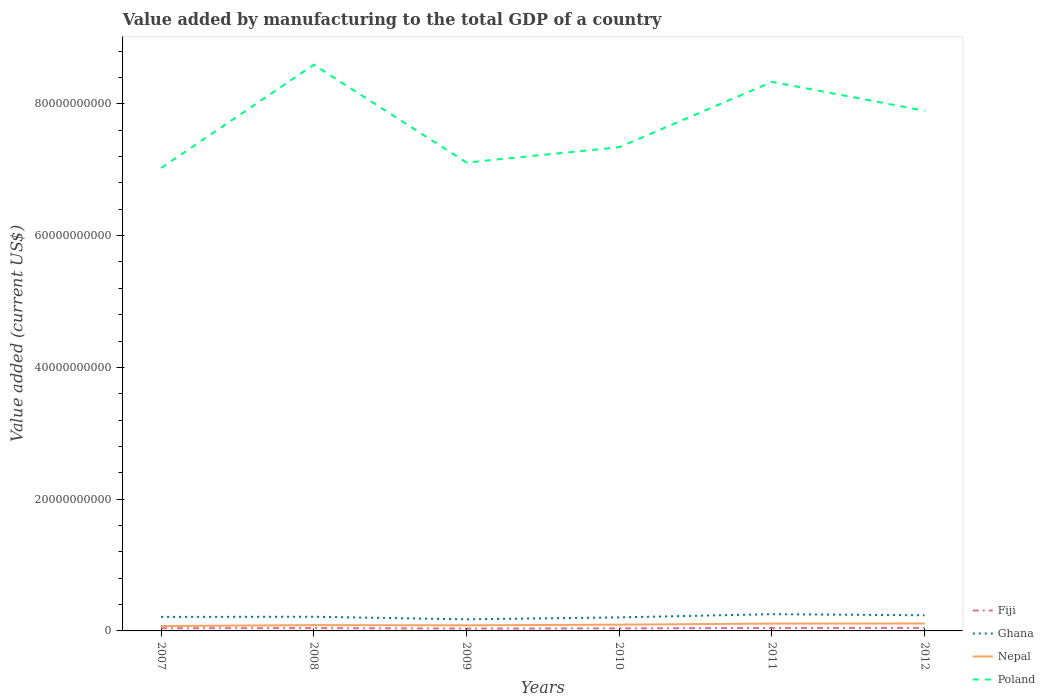Across all years, what is the maximum value added by manufacturing to the total GDP in Ghana?
Your answer should be compact. 1.76e+09. In which year was the value added by manufacturing to the total GDP in Nepal maximum?
Your answer should be compact. 2007. What is the total value added by manufacturing to the total GDP in Ghana in the graph?
Your response must be concise. 3.93e+08. What is the difference between the highest and the second highest value added by manufacturing to the total GDP in Nepal?
Your response must be concise. 3.85e+08. How many years are there in the graph?
Offer a very short reply. 6. Are the values on the major ticks of Y-axis written in scientific E-notation?
Keep it short and to the point. No. Does the graph contain grids?
Your answer should be compact. No. How many legend labels are there?
Provide a short and direct response. 4. How are the legend labels stacked?
Offer a terse response. Vertical. What is the title of the graph?
Make the answer very short. Value added by manufacturing to the total GDP of a country. Does "Mali" appear as one of the legend labels in the graph?
Provide a short and direct response. No. What is the label or title of the Y-axis?
Your response must be concise. Value added (current US$). What is the Value added (current US$) of Fiji in 2007?
Provide a succinct answer. 4.09e+08. What is the Value added (current US$) of Ghana in 2007?
Ensure brevity in your answer.  2.13e+09. What is the Value added (current US$) of Nepal in 2007?
Your answer should be very brief. 7.40e+08. What is the Value added (current US$) of Poland in 2007?
Keep it short and to the point. 7.03e+1. What is the Value added (current US$) of Fiji in 2008?
Make the answer very short. 4.28e+08. What is the Value added (current US$) in Ghana in 2008?
Provide a succinct answer. 2.15e+09. What is the Value added (current US$) of Nepal in 2008?
Provide a short and direct response. 8.80e+08. What is the Value added (current US$) in Poland in 2008?
Ensure brevity in your answer.  8.59e+1. What is the Value added (current US$) in Fiji in 2009?
Your answer should be compact. 3.53e+08. What is the Value added (current US$) of Ghana in 2009?
Make the answer very short. 1.76e+09. What is the Value added (current US$) in Nepal in 2009?
Make the answer very short. 8.51e+08. What is the Value added (current US$) in Poland in 2009?
Make the answer very short. 7.11e+1. What is the Value added (current US$) in Fiji in 2010?
Offer a very short reply. 3.87e+08. What is the Value added (current US$) in Ghana in 2010?
Offer a very short reply. 2.06e+09. What is the Value added (current US$) in Nepal in 2010?
Keep it short and to the point. 9.52e+08. What is the Value added (current US$) in Poland in 2010?
Your answer should be compact. 7.34e+1. What is the Value added (current US$) of Fiji in 2011?
Make the answer very short. 4.50e+08. What is the Value added (current US$) in Ghana in 2011?
Offer a very short reply. 2.54e+09. What is the Value added (current US$) of Nepal in 2011?
Ensure brevity in your answer.  1.11e+09. What is the Value added (current US$) in Poland in 2011?
Provide a short and direct response. 8.33e+1. What is the Value added (current US$) in Fiji in 2012?
Offer a very short reply. 4.59e+08. What is the Value added (current US$) in Ghana in 2012?
Give a very brief answer. 2.37e+09. What is the Value added (current US$) of Nepal in 2012?
Make the answer very short. 1.13e+09. What is the Value added (current US$) in Poland in 2012?
Provide a succinct answer. 7.89e+1. Across all years, what is the maximum Value added (current US$) of Fiji?
Your response must be concise. 4.59e+08. Across all years, what is the maximum Value added (current US$) of Ghana?
Provide a succinct answer. 2.54e+09. Across all years, what is the maximum Value added (current US$) of Nepal?
Your answer should be compact. 1.13e+09. Across all years, what is the maximum Value added (current US$) of Poland?
Provide a short and direct response. 8.59e+1. Across all years, what is the minimum Value added (current US$) in Fiji?
Make the answer very short. 3.53e+08. Across all years, what is the minimum Value added (current US$) in Ghana?
Provide a succinct answer. 1.76e+09. Across all years, what is the minimum Value added (current US$) in Nepal?
Your response must be concise. 7.40e+08. Across all years, what is the minimum Value added (current US$) in Poland?
Your answer should be very brief. 7.03e+1. What is the total Value added (current US$) of Fiji in the graph?
Provide a short and direct response. 2.49e+09. What is the total Value added (current US$) of Ghana in the graph?
Your answer should be compact. 1.30e+1. What is the total Value added (current US$) in Nepal in the graph?
Ensure brevity in your answer.  5.66e+09. What is the total Value added (current US$) in Poland in the graph?
Your answer should be very brief. 4.63e+11. What is the difference between the Value added (current US$) in Fiji in 2007 and that in 2008?
Your answer should be compact. -1.92e+07. What is the difference between the Value added (current US$) of Ghana in 2007 and that in 2008?
Ensure brevity in your answer.  -2.37e+07. What is the difference between the Value added (current US$) of Nepal in 2007 and that in 2008?
Give a very brief answer. -1.39e+08. What is the difference between the Value added (current US$) of Poland in 2007 and that in 2008?
Your response must be concise. -1.57e+1. What is the difference between the Value added (current US$) of Fiji in 2007 and that in 2009?
Your response must be concise. 5.59e+07. What is the difference between the Value added (current US$) of Ghana in 2007 and that in 2009?
Your answer should be very brief. 3.69e+08. What is the difference between the Value added (current US$) in Nepal in 2007 and that in 2009?
Ensure brevity in your answer.  -1.11e+08. What is the difference between the Value added (current US$) of Poland in 2007 and that in 2009?
Offer a very short reply. -8.25e+08. What is the difference between the Value added (current US$) in Fiji in 2007 and that in 2010?
Offer a very short reply. 2.25e+07. What is the difference between the Value added (current US$) in Ghana in 2007 and that in 2010?
Give a very brief answer. 7.28e+07. What is the difference between the Value added (current US$) in Nepal in 2007 and that in 2010?
Ensure brevity in your answer.  -2.11e+08. What is the difference between the Value added (current US$) in Poland in 2007 and that in 2010?
Give a very brief answer. -3.16e+09. What is the difference between the Value added (current US$) in Fiji in 2007 and that in 2011?
Give a very brief answer. -4.10e+07. What is the difference between the Value added (current US$) of Ghana in 2007 and that in 2011?
Provide a short and direct response. -4.13e+08. What is the difference between the Value added (current US$) in Nepal in 2007 and that in 2011?
Your answer should be compact. -3.74e+08. What is the difference between the Value added (current US$) of Poland in 2007 and that in 2011?
Your response must be concise. -1.31e+1. What is the difference between the Value added (current US$) in Fiji in 2007 and that in 2012?
Ensure brevity in your answer.  -5.01e+07. What is the difference between the Value added (current US$) in Ghana in 2007 and that in 2012?
Your answer should be very brief. -2.46e+08. What is the difference between the Value added (current US$) of Nepal in 2007 and that in 2012?
Make the answer very short. -3.85e+08. What is the difference between the Value added (current US$) in Poland in 2007 and that in 2012?
Give a very brief answer. -8.69e+09. What is the difference between the Value added (current US$) of Fiji in 2008 and that in 2009?
Make the answer very short. 7.51e+07. What is the difference between the Value added (current US$) in Ghana in 2008 and that in 2009?
Your answer should be compact. 3.93e+08. What is the difference between the Value added (current US$) in Nepal in 2008 and that in 2009?
Provide a short and direct response. 2.82e+07. What is the difference between the Value added (current US$) of Poland in 2008 and that in 2009?
Make the answer very short. 1.48e+1. What is the difference between the Value added (current US$) of Fiji in 2008 and that in 2010?
Your answer should be compact. 4.17e+07. What is the difference between the Value added (current US$) of Ghana in 2008 and that in 2010?
Provide a succinct answer. 9.66e+07. What is the difference between the Value added (current US$) of Nepal in 2008 and that in 2010?
Ensure brevity in your answer.  -7.20e+07. What is the difference between the Value added (current US$) of Poland in 2008 and that in 2010?
Your response must be concise. 1.25e+1. What is the difference between the Value added (current US$) in Fiji in 2008 and that in 2011?
Keep it short and to the point. -2.18e+07. What is the difference between the Value added (current US$) in Ghana in 2008 and that in 2011?
Provide a succinct answer. -3.90e+08. What is the difference between the Value added (current US$) of Nepal in 2008 and that in 2011?
Keep it short and to the point. -2.35e+08. What is the difference between the Value added (current US$) of Poland in 2008 and that in 2011?
Provide a succinct answer. 2.60e+09. What is the difference between the Value added (current US$) of Fiji in 2008 and that in 2012?
Offer a very short reply. -3.10e+07. What is the difference between the Value added (current US$) of Ghana in 2008 and that in 2012?
Make the answer very short. -2.22e+08. What is the difference between the Value added (current US$) of Nepal in 2008 and that in 2012?
Your answer should be compact. -2.46e+08. What is the difference between the Value added (current US$) in Poland in 2008 and that in 2012?
Keep it short and to the point. 6.98e+09. What is the difference between the Value added (current US$) of Fiji in 2009 and that in 2010?
Offer a very short reply. -3.34e+07. What is the difference between the Value added (current US$) in Ghana in 2009 and that in 2010?
Ensure brevity in your answer.  -2.96e+08. What is the difference between the Value added (current US$) in Nepal in 2009 and that in 2010?
Your answer should be compact. -1.00e+08. What is the difference between the Value added (current US$) of Poland in 2009 and that in 2010?
Your answer should be compact. -2.33e+09. What is the difference between the Value added (current US$) in Fiji in 2009 and that in 2011?
Keep it short and to the point. -9.69e+07. What is the difference between the Value added (current US$) in Ghana in 2009 and that in 2011?
Offer a very short reply. -7.82e+08. What is the difference between the Value added (current US$) in Nepal in 2009 and that in 2011?
Provide a succinct answer. -2.63e+08. What is the difference between the Value added (current US$) of Poland in 2009 and that in 2011?
Make the answer very short. -1.22e+1. What is the difference between the Value added (current US$) of Fiji in 2009 and that in 2012?
Ensure brevity in your answer.  -1.06e+08. What is the difference between the Value added (current US$) of Ghana in 2009 and that in 2012?
Offer a terse response. -6.15e+08. What is the difference between the Value added (current US$) in Nepal in 2009 and that in 2012?
Keep it short and to the point. -2.74e+08. What is the difference between the Value added (current US$) of Poland in 2009 and that in 2012?
Offer a terse response. -7.86e+09. What is the difference between the Value added (current US$) in Fiji in 2010 and that in 2011?
Provide a short and direct response. -6.35e+07. What is the difference between the Value added (current US$) of Ghana in 2010 and that in 2011?
Offer a very short reply. -4.86e+08. What is the difference between the Value added (current US$) of Nepal in 2010 and that in 2011?
Provide a short and direct response. -1.63e+08. What is the difference between the Value added (current US$) of Poland in 2010 and that in 2011?
Keep it short and to the point. -9.91e+09. What is the difference between the Value added (current US$) of Fiji in 2010 and that in 2012?
Keep it short and to the point. -7.26e+07. What is the difference between the Value added (current US$) of Ghana in 2010 and that in 2012?
Your response must be concise. -3.18e+08. What is the difference between the Value added (current US$) in Nepal in 2010 and that in 2012?
Offer a very short reply. -1.74e+08. What is the difference between the Value added (current US$) of Poland in 2010 and that in 2012?
Make the answer very short. -5.53e+09. What is the difference between the Value added (current US$) in Fiji in 2011 and that in 2012?
Offer a terse response. -9.15e+06. What is the difference between the Value added (current US$) in Ghana in 2011 and that in 2012?
Ensure brevity in your answer.  1.68e+08. What is the difference between the Value added (current US$) of Nepal in 2011 and that in 2012?
Your answer should be compact. -1.10e+07. What is the difference between the Value added (current US$) of Poland in 2011 and that in 2012?
Ensure brevity in your answer.  4.38e+09. What is the difference between the Value added (current US$) in Fiji in 2007 and the Value added (current US$) in Ghana in 2008?
Your answer should be very brief. -1.74e+09. What is the difference between the Value added (current US$) in Fiji in 2007 and the Value added (current US$) in Nepal in 2008?
Offer a very short reply. -4.70e+08. What is the difference between the Value added (current US$) of Fiji in 2007 and the Value added (current US$) of Poland in 2008?
Your response must be concise. -8.55e+1. What is the difference between the Value added (current US$) in Ghana in 2007 and the Value added (current US$) in Nepal in 2008?
Provide a succinct answer. 1.25e+09. What is the difference between the Value added (current US$) in Ghana in 2007 and the Value added (current US$) in Poland in 2008?
Your answer should be very brief. -8.38e+1. What is the difference between the Value added (current US$) of Nepal in 2007 and the Value added (current US$) of Poland in 2008?
Your response must be concise. -8.52e+1. What is the difference between the Value added (current US$) in Fiji in 2007 and the Value added (current US$) in Ghana in 2009?
Make the answer very short. -1.35e+09. What is the difference between the Value added (current US$) in Fiji in 2007 and the Value added (current US$) in Nepal in 2009?
Make the answer very short. -4.42e+08. What is the difference between the Value added (current US$) in Fiji in 2007 and the Value added (current US$) in Poland in 2009?
Your answer should be very brief. -7.07e+1. What is the difference between the Value added (current US$) in Ghana in 2007 and the Value added (current US$) in Nepal in 2009?
Give a very brief answer. 1.28e+09. What is the difference between the Value added (current US$) in Ghana in 2007 and the Value added (current US$) in Poland in 2009?
Your answer should be very brief. -6.90e+1. What is the difference between the Value added (current US$) of Nepal in 2007 and the Value added (current US$) of Poland in 2009?
Your response must be concise. -7.03e+1. What is the difference between the Value added (current US$) in Fiji in 2007 and the Value added (current US$) in Ghana in 2010?
Keep it short and to the point. -1.65e+09. What is the difference between the Value added (current US$) in Fiji in 2007 and the Value added (current US$) in Nepal in 2010?
Your response must be concise. -5.42e+08. What is the difference between the Value added (current US$) of Fiji in 2007 and the Value added (current US$) of Poland in 2010?
Offer a terse response. -7.30e+1. What is the difference between the Value added (current US$) in Ghana in 2007 and the Value added (current US$) in Nepal in 2010?
Provide a succinct answer. 1.18e+09. What is the difference between the Value added (current US$) in Ghana in 2007 and the Value added (current US$) in Poland in 2010?
Offer a terse response. -7.13e+1. What is the difference between the Value added (current US$) of Nepal in 2007 and the Value added (current US$) of Poland in 2010?
Keep it short and to the point. -7.27e+1. What is the difference between the Value added (current US$) of Fiji in 2007 and the Value added (current US$) of Ghana in 2011?
Offer a very short reply. -2.13e+09. What is the difference between the Value added (current US$) in Fiji in 2007 and the Value added (current US$) in Nepal in 2011?
Give a very brief answer. -7.05e+08. What is the difference between the Value added (current US$) of Fiji in 2007 and the Value added (current US$) of Poland in 2011?
Offer a terse response. -8.29e+1. What is the difference between the Value added (current US$) in Ghana in 2007 and the Value added (current US$) in Nepal in 2011?
Offer a terse response. 1.01e+09. What is the difference between the Value added (current US$) of Ghana in 2007 and the Value added (current US$) of Poland in 2011?
Ensure brevity in your answer.  -8.12e+1. What is the difference between the Value added (current US$) of Nepal in 2007 and the Value added (current US$) of Poland in 2011?
Provide a succinct answer. -8.26e+1. What is the difference between the Value added (current US$) in Fiji in 2007 and the Value added (current US$) in Ghana in 2012?
Your response must be concise. -1.96e+09. What is the difference between the Value added (current US$) of Fiji in 2007 and the Value added (current US$) of Nepal in 2012?
Keep it short and to the point. -7.16e+08. What is the difference between the Value added (current US$) in Fiji in 2007 and the Value added (current US$) in Poland in 2012?
Make the answer very short. -7.85e+1. What is the difference between the Value added (current US$) in Ghana in 2007 and the Value added (current US$) in Nepal in 2012?
Provide a short and direct response. 1.00e+09. What is the difference between the Value added (current US$) of Ghana in 2007 and the Value added (current US$) of Poland in 2012?
Make the answer very short. -7.68e+1. What is the difference between the Value added (current US$) in Nepal in 2007 and the Value added (current US$) in Poland in 2012?
Your answer should be compact. -7.82e+1. What is the difference between the Value added (current US$) of Fiji in 2008 and the Value added (current US$) of Ghana in 2009?
Offer a terse response. -1.33e+09. What is the difference between the Value added (current US$) of Fiji in 2008 and the Value added (current US$) of Nepal in 2009?
Provide a short and direct response. -4.23e+08. What is the difference between the Value added (current US$) in Fiji in 2008 and the Value added (current US$) in Poland in 2009?
Keep it short and to the point. -7.07e+1. What is the difference between the Value added (current US$) in Ghana in 2008 and the Value added (current US$) in Nepal in 2009?
Your answer should be very brief. 1.30e+09. What is the difference between the Value added (current US$) of Ghana in 2008 and the Value added (current US$) of Poland in 2009?
Your answer should be compact. -6.89e+1. What is the difference between the Value added (current US$) of Nepal in 2008 and the Value added (current US$) of Poland in 2009?
Ensure brevity in your answer.  -7.02e+1. What is the difference between the Value added (current US$) in Fiji in 2008 and the Value added (current US$) in Ghana in 2010?
Keep it short and to the point. -1.63e+09. What is the difference between the Value added (current US$) in Fiji in 2008 and the Value added (current US$) in Nepal in 2010?
Your answer should be very brief. -5.23e+08. What is the difference between the Value added (current US$) in Fiji in 2008 and the Value added (current US$) in Poland in 2010?
Ensure brevity in your answer.  -7.30e+1. What is the difference between the Value added (current US$) in Ghana in 2008 and the Value added (current US$) in Nepal in 2010?
Ensure brevity in your answer.  1.20e+09. What is the difference between the Value added (current US$) of Ghana in 2008 and the Value added (current US$) of Poland in 2010?
Your answer should be very brief. -7.13e+1. What is the difference between the Value added (current US$) of Nepal in 2008 and the Value added (current US$) of Poland in 2010?
Offer a terse response. -7.25e+1. What is the difference between the Value added (current US$) of Fiji in 2008 and the Value added (current US$) of Ghana in 2011?
Keep it short and to the point. -2.11e+09. What is the difference between the Value added (current US$) of Fiji in 2008 and the Value added (current US$) of Nepal in 2011?
Provide a succinct answer. -6.86e+08. What is the difference between the Value added (current US$) in Fiji in 2008 and the Value added (current US$) in Poland in 2011?
Provide a short and direct response. -8.29e+1. What is the difference between the Value added (current US$) of Ghana in 2008 and the Value added (current US$) of Nepal in 2011?
Keep it short and to the point. 1.04e+09. What is the difference between the Value added (current US$) in Ghana in 2008 and the Value added (current US$) in Poland in 2011?
Your response must be concise. -8.12e+1. What is the difference between the Value added (current US$) in Nepal in 2008 and the Value added (current US$) in Poland in 2011?
Offer a terse response. -8.24e+1. What is the difference between the Value added (current US$) of Fiji in 2008 and the Value added (current US$) of Ghana in 2012?
Make the answer very short. -1.95e+09. What is the difference between the Value added (current US$) in Fiji in 2008 and the Value added (current US$) in Nepal in 2012?
Your response must be concise. -6.97e+08. What is the difference between the Value added (current US$) of Fiji in 2008 and the Value added (current US$) of Poland in 2012?
Offer a terse response. -7.85e+1. What is the difference between the Value added (current US$) in Ghana in 2008 and the Value added (current US$) in Nepal in 2012?
Your answer should be compact. 1.03e+09. What is the difference between the Value added (current US$) of Ghana in 2008 and the Value added (current US$) of Poland in 2012?
Your answer should be very brief. -7.68e+1. What is the difference between the Value added (current US$) of Nepal in 2008 and the Value added (current US$) of Poland in 2012?
Your answer should be very brief. -7.81e+1. What is the difference between the Value added (current US$) of Fiji in 2009 and the Value added (current US$) of Ghana in 2010?
Give a very brief answer. -1.70e+09. What is the difference between the Value added (current US$) of Fiji in 2009 and the Value added (current US$) of Nepal in 2010?
Your response must be concise. -5.98e+08. What is the difference between the Value added (current US$) of Fiji in 2009 and the Value added (current US$) of Poland in 2010?
Your answer should be compact. -7.31e+1. What is the difference between the Value added (current US$) in Ghana in 2009 and the Value added (current US$) in Nepal in 2010?
Give a very brief answer. 8.08e+08. What is the difference between the Value added (current US$) in Ghana in 2009 and the Value added (current US$) in Poland in 2010?
Provide a succinct answer. -7.17e+1. What is the difference between the Value added (current US$) of Nepal in 2009 and the Value added (current US$) of Poland in 2010?
Your response must be concise. -7.26e+1. What is the difference between the Value added (current US$) in Fiji in 2009 and the Value added (current US$) in Ghana in 2011?
Provide a succinct answer. -2.19e+09. What is the difference between the Value added (current US$) of Fiji in 2009 and the Value added (current US$) of Nepal in 2011?
Provide a succinct answer. -7.61e+08. What is the difference between the Value added (current US$) of Fiji in 2009 and the Value added (current US$) of Poland in 2011?
Provide a succinct answer. -8.30e+1. What is the difference between the Value added (current US$) of Ghana in 2009 and the Value added (current US$) of Nepal in 2011?
Give a very brief answer. 6.45e+08. What is the difference between the Value added (current US$) of Ghana in 2009 and the Value added (current US$) of Poland in 2011?
Offer a terse response. -8.16e+1. What is the difference between the Value added (current US$) of Nepal in 2009 and the Value added (current US$) of Poland in 2011?
Keep it short and to the point. -8.25e+1. What is the difference between the Value added (current US$) of Fiji in 2009 and the Value added (current US$) of Ghana in 2012?
Your answer should be very brief. -2.02e+09. What is the difference between the Value added (current US$) in Fiji in 2009 and the Value added (current US$) in Nepal in 2012?
Your answer should be compact. -7.72e+08. What is the difference between the Value added (current US$) of Fiji in 2009 and the Value added (current US$) of Poland in 2012?
Offer a terse response. -7.86e+1. What is the difference between the Value added (current US$) of Ghana in 2009 and the Value added (current US$) of Nepal in 2012?
Give a very brief answer. 6.34e+08. What is the difference between the Value added (current US$) of Ghana in 2009 and the Value added (current US$) of Poland in 2012?
Make the answer very short. -7.72e+1. What is the difference between the Value added (current US$) in Nepal in 2009 and the Value added (current US$) in Poland in 2012?
Offer a terse response. -7.81e+1. What is the difference between the Value added (current US$) of Fiji in 2010 and the Value added (current US$) of Ghana in 2011?
Make the answer very short. -2.16e+09. What is the difference between the Value added (current US$) of Fiji in 2010 and the Value added (current US$) of Nepal in 2011?
Your response must be concise. -7.28e+08. What is the difference between the Value added (current US$) of Fiji in 2010 and the Value added (current US$) of Poland in 2011?
Your response must be concise. -8.29e+1. What is the difference between the Value added (current US$) of Ghana in 2010 and the Value added (current US$) of Nepal in 2011?
Make the answer very short. 9.41e+08. What is the difference between the Value added (current US$) in Ghana in 2010 and the Value added (current US$) in Poland in 2011?
Give a very brief answer. -8.13e+1. What is the difference between the Value added (current US$) in Nepal in 2010 and the Value added (current US$) in Poland in 2011?
Ensure brevity in your answer.  -8.24e+1. What is the difference between the Value added (current US$) of Fiji in 2010 and the Value added (current US$) of Ghana in 2012?
Make the answer very short. -1.99e+09. What is the difference between the Value added (current US$) of Fiji in 2010 and the Value added (current US$) of Nepal in 2012?
Provide a short and direct response. -7.39e+08. What is the difference between the Value added (current US$) of Fiji in 2010 and the Value added (current US$) of Poland in 2012?
Your answer should be compact. -7.86e+1. What is the difference between the Value added (current US$) of Ghana in 2010 and the Value added (current US$) of Nepal in 2012?
Provide a short and direct response. 9.30e+08. What is the difference between the Value added (current US$) of Ghana in 2010 and the Value added (current US$) of Poland in 2012?
Make the answer very short. -7.69e+1. What is the difference between the Value added (current US$) in Nepal in 2010 and the Value added (current US$) in Poland in 2012?
Keep it short and to the point. -7.80e+1. What is the difference between the Value added (current US$) in Fiji in 2011 and the Value added (current US$) in Ghana in 2012?
Keep it short and to the point. -1.92e+09. What is the difference between the Value added (current US$) in Fiji in 2011 and the Value added (current US$) in Nepal in 2012?
Keep it short and to the point. -6.75e+08. What is the difference between the Value added (current US$) in Fiji in 2011 and the Value added (current US$) in Poland in 2012?
Ensure brevity in your answer.  -7.85e+1. What is the difference between the Value added (current US$) in Ghana in 2011 and the Value added (current US$) in Nepal in 2012?
Make the answer very short. 1.42e+09. What is the difference between the Value added (current US$) of Ghana in 2011 and the Value added (current US$) of Poland in 2012?
Keep it short and to the point. -7.64e+1. What is the difference between the Value added (current US$) of Nepal in 2011 and the Value added (current US$) of Poland in 2012?
Make the answer very short. -7.78e+1. What is the average Value added (current US$) of Fiji per year?
Ensure brevity in your answer.  4.14e+08. What is the average Value added (current US$) of Ghana per year?
Your answer should be compact. 2.17e+09. What is the average Value added (current US$) in Nepal per year?
Your answer should be very brief. 9.44e+08. What is the average Value added (current US$) of Poland per year?
Keep it short and to the point. 7.72e+1. In the year 2007, what is the difference between the Value added (current US$) in Fiji and Value added (current US$) in Ghana?
Offer a very short reply. -1.72e+09. In the year 2007, what is the difference between the Value added (current US$) of Fiji and Value added (current US$) of Nepal?
Provide a succinct answer. -3.31e+08. In the year 2007, what is the difference between the Value added (current US$) in Fiji and Value added (current US$) in Poland?
Provide a short and direct response. -6.98e+1. In the year 2007, what is the difference between the Value added (current US$) of Ghana and Value added (current US$) of Nepal?
Your answer should be very brief. 1.39e+09. In the year 2007, what is the difference between the Value added (current US$) in Ghana and Value added (current US$) in Poland?
Offer a terse response. -6.81e+1. In the year 2007, what is the difference between the Value added (current US$) in Nepal and Value added (current US$) in Poland?
Give a very brief answer. -6.95e+1. In the year 2008, what is the difference between the Value added (current US$) of Fiji and Value added (current US$) of Ghana?
Your answer should be compact. -1.72e+09. In the year 2008, what is the difference between the Value added (current US$) of Fiji and Value added (current US$) of Nepal?
Your answer should be compact. -4.51e+08. In the year 2008, what is the difference between the Value added (current US$) in Fiji and Value added (current US$) in Poland?
Ensure brevity in your answer.  -8.55e+1. In the year 2008, what is the difference between the Value added (current US$) in Ghana and Value added (current US$) in Nepal?
Give a very brief answer. 1.27e+09. In the year 2008, what is the difference between the Value added (current US$) of Ghana and Value added (current US$) of Poland?
Offer a very short reply. -8.38e+1. In the year 2008, what is the difference between the Value added (current US$) of Nepal and Value added (current US$) of Poland?
Keep it short and to the point. -8.50e+1. In the year 2009, what is the difference between the Value added (current US$) in Fiji and Value added (current US$) in Ghana?
Provide a short and direct response. -1.41e+09. In the year 2009, what is the difference between the Value added (current US$) of Fiji and Value added (current US$) of Nepal?
Provide a succinct answer. -4.98e+08. In the year 2009, what is the difference between the Value added (current US$) in Fiji and Value added (current US$) in Poland?
Provide a short and direct response. -7.07e+1. In the year 2009, what is the difference between the Value added (current US$) in Ghana and Value added (current US$) in Nepal?
Your answer should be compact. 9.08e+08. In the year 2009, what is the difference between the Value added (current US$) of Ghana and Value added (current US$) of Poland?
Give a very brief answer. -6.93e+1. In the year 2009, what is the difference between the Value added (current US$) of Nepal and Value added (current US$) of Poland?
Ensure brevity in your answer.  -7.02e+1. In the year 2010, what is the difference between the Value added (current US$) of Fiji and Value added (current US$) of Ghana?
Offer a very short reply. -1.67e+09. In the year 2010, what is the difference between the Value added (current US$) in Fiji and Value added (current US$) in Nepal?
Your response must be concise. -5.65e+08. In the year 2010, what is the difference between the Value added (current US$) in Fiji and Value added (current US$) in Poland?
Provide a succinct answer. -7.30e+1. In the year 2010, what is the difference between the Value added (current US$) of Ghana and Value added (current US$) of Nepal?
Your response must be concise. 1.10e+09. In the year 2010, what is the difference between the Value added (current US$) of Ghana and Value added (current US$) of Poland?
Ensure brevity in your answer.  -7.14e+1. In the year 2010, what is the difference between the Value added (current US$) in Nepal and Value added (current US$) in Poland?
Your response must be concise. -7.25e+1. In the year 2011, what is the difference between the Value added (current US$) in Fiji and Value added (current US$) in Ghana?
Provide a short and direct response. -2.09e+09. In the year 2011, what is the difference between the Value added (current US$) in Fiji and Value added (current US$) in Nepal?
Your answer should be compact. -6.64e+08. In the year 2011, what is the difference between the Value added (current US$) in Fiji and Value added (current US$) in Poland?
Your answer should be compact. -8.29e+1. In the year 2011, what is the difference between the Value added (current US$) of Ghana and Value added (current US$) of Nepal?
Make the answer very short. 1.43e+09. In the year 2011, what is the difference between the Value added (current US$) in Ghana and Value added (current US$) in Poland?
Give a very brief answer. -8.08e+1. In the year 2011, what is the difference between the Value added (current US$) of Nepal and Value added (current US$) of Poland?
Your answer should be very brief. -8.22e+1. In the year 2012, what is the difference between the Value added (current US$) of Fiji and Value added (current US$) of Ghana?
Your answer should be very brief. -1.91e+09. In the year 2012, what is the difference between the Value added (current US$) of Fiji and Value added (current US$) of Nepal?
Make the answer very short. -6.66e+08. In the year 2012, what is the difference between the Value added (current US$) of Fiji and Value added (current US$) of Poland?
Give a very brief answer. -7.85e+1. In the year 2012, what is the difference between the Value added (current US$) in Ghana and Value added (current US$) in Nepal?
Offer a very short reply. 1.25e+09. In the year 2012, what is the difference between the Value added (current US$) in Ghana and Value added (current US$) in Poland?
Offer a very short reply. -7.66e+1. In the year 2012, what is the difference between the Value added (current US$) of Nepal and Value added (current US$) of Poland?
Provide a succinct answer. -7.78e+1. What is the ratio of the Value added (current US$) of Fiji in 2007 to that in 2008?
Keep it short and to the point. 0.96. What is the ratio of the Value added (current US$) of Nepal in 2007 to that in 2008?
Keep it short and to the point. 0.84. What is the ratio of the Value added (current US$) in Poland in 2007 to that in 2008?
Your answer should be very brief. 0.82. What is the ratio of the Value added (current US$) of Fiji in 2007 to that in 2009?
Ensure brevity in your answer.  1.16. What is the ratio of the Value added (current US$) in Ghana in 2007 to that in 2009?
Provide a short and direct response. 1.21. What is the ratio of the Value added (current US$) in Nepal in 2007 to that in 2009?
Make the answer very short. 0.87. What is the ratio of the Value added (current US$) of Poland in 2007 to that in 2009?
Make the answer very short. 0.99. What is the ratio of the Value added (current US$) of Fiji in 2007 to that in 2010?
Ensure brevity in your answer.  1.06. What is the ratio of the Value added (current US$) of Ghana in 2007 to that in 2010?
Give a very brief answer. 1.04. What is the ratio of the Value added (current US$) in Nepal in 2007 to that in 2010?
Provide a succinct answer. 0.78. What is the ratio of the Value added (current US$) in Fiji in 2007 to that in 2011?
Your response must be concise. 0.91. What is the ratio of the Value added (current US$) of Ghana in 2007 to that in 2011?
Your answer should be very brief. 0.84. What is the ratio of the Value added (current US$) in Nepal in 2007 to that in 2011?
Your response must be concise. 0.66. What is the ratio of the Value added (current US$) in Poland in 2007 to that in 2011?
Offer a very short reply. 0.84. What is the ratio of the Value added (current US$) in Fiji in 2007 to that in 2012?
Ensure brevity in your answer.  0.89. What is the ratio of the Value added (current US$) in Ghana in 2007 to that in 2012?
Provide a succinct answer. 0.9. What is the ratio of the Value added (current US$) in Nepal in 2007 to that in 2012?
Offer a terse response. 0.66. What is the ratio of the Value added (current US$) in Poland in 2007 to that in 2012?
Your answer should be very brief. 0.89. What is the ratio of the Value added (current US$) in Fiji in 2008 to that in 2009?
Give a very brief answer. 1.21. What is the ratio of the Value added (current US$) of Ghana in 2008 to that in 2009?
Offer a very short reply. 1.22. What is the ratio of the Value added (current US$) of Nepal in 2008 to that in 2009?
Offer a terse response. 1.03. What is the ratio of the Value added (current US$) in Poland in 2008 to that in 2009?
Keep it short and to the point. 1.21. What is the ratio of the Value added (current US$) in Fiji in 2008 to that in 2010?
Ensure brevity in your answer.  1.11. What is the ratio of the Value added (current US$) of Ghana in 2008 to that in 2010?
Give a very brief answer. 1.05. What is the ratio of the Value added (current US$) of Nepal in 2008 to that in 2010?
Give a very brief answer. 0.92. What is the ratio of the Value added (current US$) in Poland in 2008 to that in 2010?
Ensure brevity in your answer.  1.17. What is the ratio of the Value added (current US$) in Fiji in 2008 to that in 2011?
Your answer should be very brief. 0.95. What is the ratio of the Value added (current US$) of Ghana in 2008 to that in 2011?
Your answer should be compact. 0.85. What is the ratio of the Value added (current US$) of Nepal in 2008 to that in 2011?
Give a very brief answer. 0.79. What is the ratio of the Value added (current US$) in Poland in 2008 to that in 2011?
Your answer should be compact. 1.03. What is the ratio of the Value added (current US$) of Fiji in 2008 to that in 2012?
Your answer should be very brief. 0.93. What is the ratio of the Value added (current US$) in Ghana in 2008 to that in 2012?
Offer a terse response. 0.91. What is the ratio of the Value added (current US$) of Nepal in 2008 to that in 2012?
Provide a succinct answer. 0.78. What is the ratio of the Value added (current US$) in Poland in 2008 to that in 2012?
Your response must be concise. 1.09. What is the ratio of the Value added (current US$) in Fiji in 2009 to that in 2010?
Keep it short and to the point. 0.91. What is the ratio of the Value added (current US$) in Ghana in 2009 to that in 2010?
Make the answer very short. 0.86. What is the ratio of the Value added (current US$) in Nepal in 2009 to that in 2010?
Offer a terse response. 0.89. What is the ratio of the Value added (current US$) in Poland in 2009 to that in 2010?
Offer a terse response. 0.97. What is the ratio of the Value added (current US$) in Fiji in 2009 to that in 2011?
Keep it short and to the point. 0.78. What is the ratio of the Value added (current US$) of Ghana in 2009 to that in 2011?
Keep it short and to the point. 0.69. What is the ratio of the Value added (current US$) in Nepal in 2009 to that in 2011?
Provide a short and direct response. 0.76. What is the ratio of the Value added (current US$) of Poland in 2009 to that in 2011?
Keep it short and to the point. 0.85. What is the ratio of the Value added (current US$) in Fiji in 2009 to that in 2012?
Provide a succinct answer. 0.77. What is the ratio of the Value added (current US$) in Ghana in 2009 to that in 2012?
Offer a very short reply. 0.74. What is the ratio of the Value added (current US$) in Nepal in 2009 to that in 2012?
Offer a very short reply. 0.76. What is the ratio of the Value added (current US$) in Poland in 2009 to that in 2012?
Your answer should be very brief. 0.9. What is the ratio of the Value added (current US$) of Fiji in 2010 to that in 2011?
Keep it short and to the point. 0.86. What is the ratio of the Value added (current US$) of Ghana in 2010 to that in 2011?
Your answer should be compact. 0.81. What is the ratio of the Value added (current US$) in Nepal in 2010 to that in 2011?
Keep it short and to the point. 0.85. What is the ratio of the Value added (current US$) of Poland in 2010 to that in 2011?
Make the answer very short. 0.88. What is the ratio of the Value added (current US$) of Fiji in 2010 to that in 2012?
Give a very brief answer. 0.84. What is the ratio of the Value added (current US$) in Ghana in 2010 to that in 2012?
Your answer should be compact. 0.87. What is the ratio of the Value added (current US$) in Nepal in 2010 to that in 2012?
Your answer should be very brief. 0.85. What is the ratio of the Value added (current US$) of Poland in 2010 to that in 2012?
Give a very brief answer. 0.93. What is the ratio of the Value added (current US$) in Fiji in 2011 to that in 2012?
Keep it short and to the point. 0.98. What is the ratio of the Value added (current US$) in Ghana in 2011 to that in 2012?
Your answer should be very brief. 1.07. What is the ratio of the Value added (current US$) in Nepal in 2011 to that in 2012?
Ensure brevity in your answer.  0.99. What is the ratio of the Value added (current US$) of Poland in 2011 to that in 2012?
Offer a terse response. 1.06. What is the difference between the highest and the second highest Value added (current US$) of Fiji?
Your answer should be compact. 9.15e+06. What is the difference between the highest and the second highest Value added (current US$) in Ghana?
Offer a terse response. 1.68e+08. What is the difference between the highest and the second highest Value added (current US$) in Nepal?
Your answer should be very brief. 1.10e+07. What is the difference between the highest and the second highest Value added (current US$) in Poland?
Ensure brevity in your answer.  2.60e+09. What is the difference between the highest and the lowest Value added (current US$) in Fiji?
Ensure brevity in your answer.  1.06e+08. What is the difference between the highest and the lowest Value added (current US$) of Ghana?
Your answer should be compact. 7.82e+08. What is the difference between the highest and the lowest Value added (current US$) in Nepal?
Offer a terse response. 3.85e+08. What is the difference between the highest and the lowest Value added (current US$) in Poland?
Make the answer very short. 1.57e+1. 